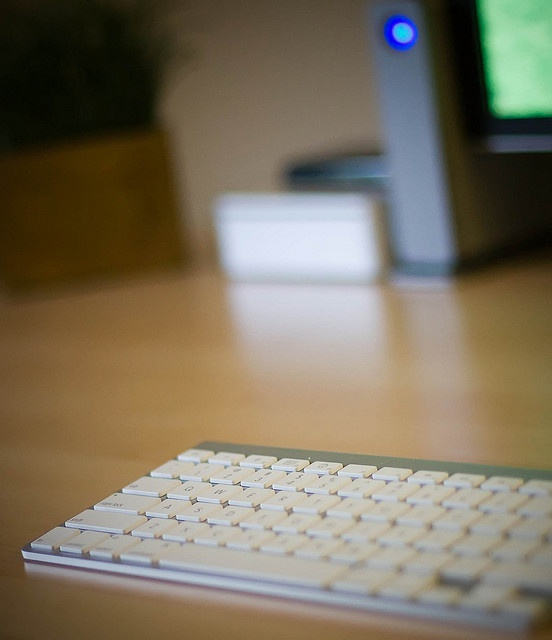Describe the objects in this image and their specific colors. I can see a keyboard in black, darkgray, lightgray, and gray tones in this image. 